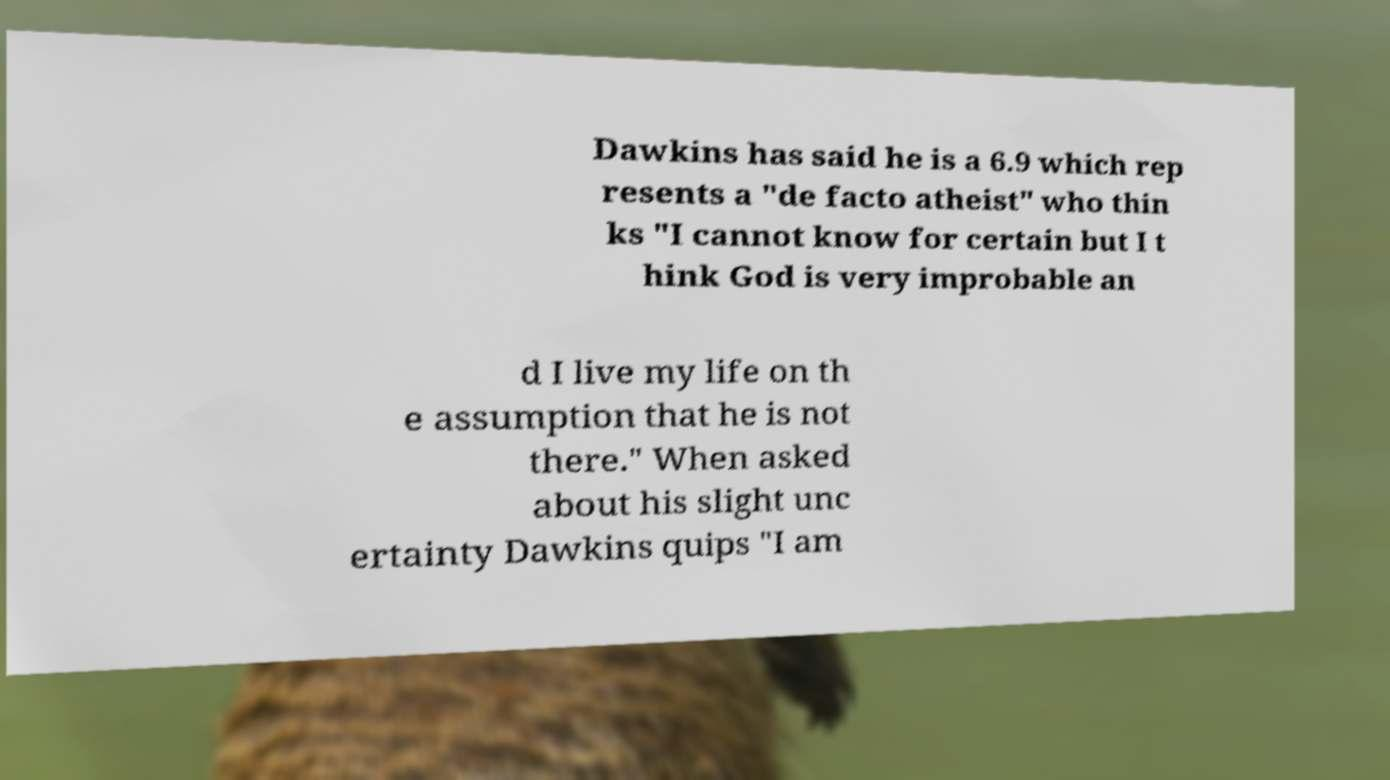Please identify and transcribe the text found in this image. Dawkins has said he is a 6.9 which rep resents a "de facto atheist" who thin ks "I cannot know for certain but I t hink God is very improbable an d I live my life on th e assumption that he is not there." When asked about his slight unc ertainty Dawkins quips "I am 